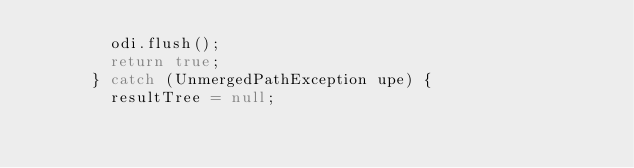<code> <loc_0><loc_0><loc_500><loc_500><_Java_>				odi.flush();
				return true;
			} catch (UnmergedPathException upe) {
				resultTree = null;</code> 